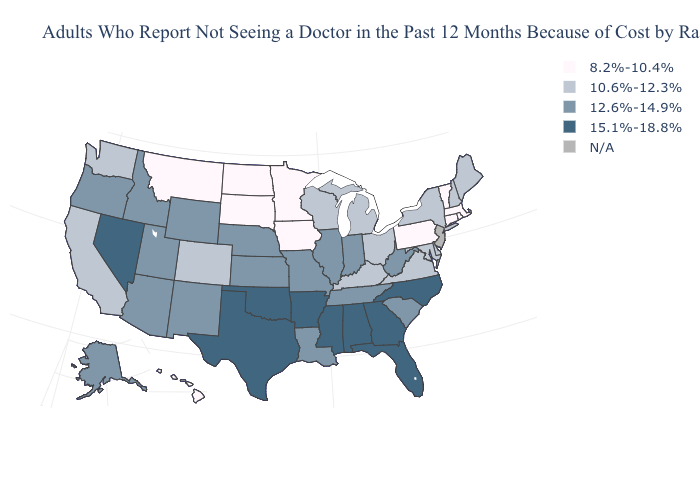What is the lowest value in the Northeast?
Answer briefly. 8.2%-10.4%. What is the value of Georgia?
Give a very brief answer. 15.1%-18.8%. What is the lowest value in the Northeast?
Give a very brief answer. 8.2%-10.4%. What is the highest value in the USA?
Answer briefly. 15.1%-18.8%. What is the value of Georgia?
Quick response, please. 15.1%-18.8%. Name the states that have a value in the range 10.6%-12.3%?
Write a very short answer. California, Colorado, Delaware, Kentucky, Maine, Maryland, Michigan, New Hampshire, New York, Ohio, Virginia, Washington, Wisconsin. Name the states that have a value in the range 15.1%-18.8%?
Give a very brief answer. Alabama, Arkansas, Florida, Georgia, Mississippi, Nevada, North Carolina, Oklahoma, Texas. Which states hav the highest value in the Northeast?
Answer briefly. Maine, New Hampshire, New York. Among the states that border West Virginia , does Pennsylvania have the lowest value?
Write a very short answer. Yes. Among the states that border Minnesota , does Wisconsin have the lowest value?
Write a very short answer. No. What is the highest value in the USA?
Answer briefly. 15.1%-18.8%. Which states hav the highest value in the West?
Be succinct. Nevada. Name the states that have a value in the range 8.2%-10.4%?
Short answer required. Connecticut, Hawaii, Iowa, Massachusetts, Minnesota, Montana, North Dakota, Pennsylvania, Rhode Island, South Dakota, Vermont. Among the states that border Nevada , does California have the highest value?
Answer briefly. No. What is the value of Oklahoma?
Give a very brief answer. 15.1%-18.8%. 